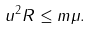Convert formula to latex. <formula><loc_0><loc_0><loc_500><loc_500>u ^ { 2 } R \leq m \mu .</formula> 